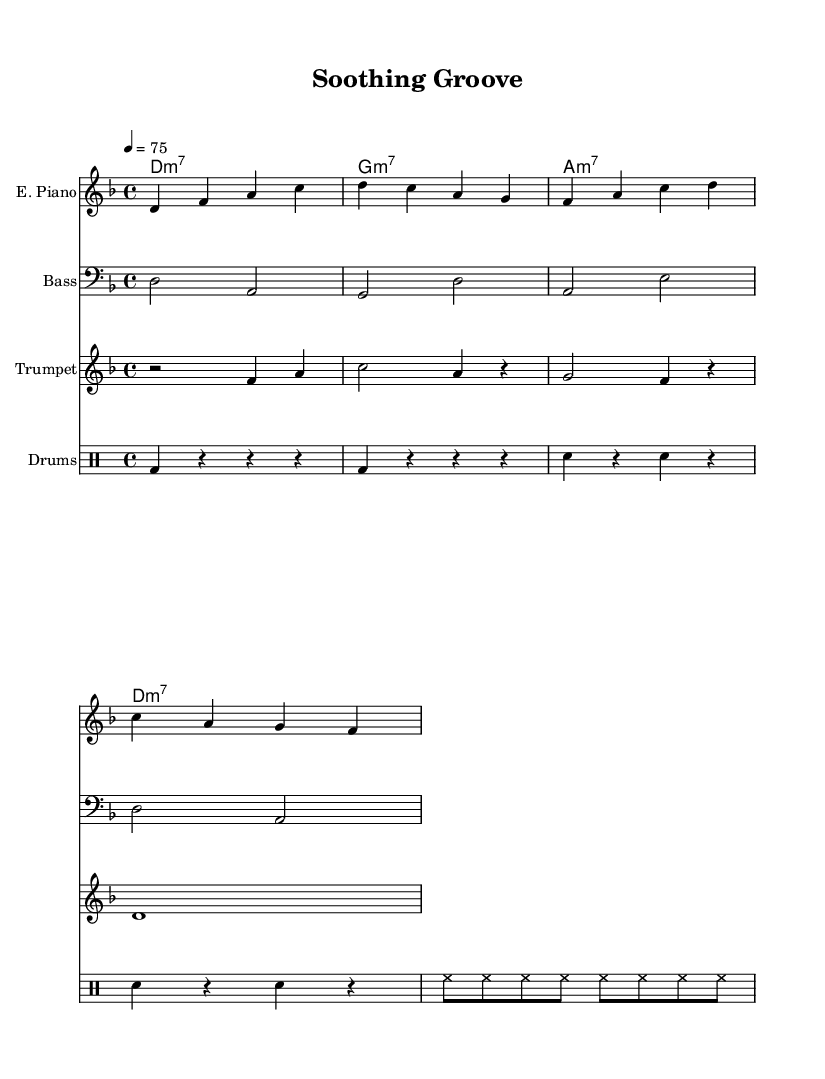What is the key signature of this music? The key signature indicated is D minor, which typically features one flat (B flat). Since no sharps or additional accidentals appear in the music, it confirms the key signature as D minor.
Answer: D minor What is the time signature of this music? The time signature shown at the beginning of the sheet music is 4/4, which means there are four beats in each measure and the quarter note receives one beat. This is a common time signature in many music styles, including funk.
Answer: 4/4 What is the tempo marking for this piece? The tempo marking indicates a speed of 75 beats per minute, written in the sheet music as "4 = 75." This suggests a moderate pace that is suitable for relaxing and mellow music.
Answer: 75 How many different instruments are included in this composition? The score displays four distinct instrument parts: electric piano, bass guitar, trumpet, and drums. Each part is represented on its own staff to illustrate the combination of sounds in the funk arrangement.
Answer: Four What kind of chord progression is used in the piece? The chord names presented show a progression consisting of D minor 7, G minor 7, A minor 7, followed by a repeat of D minor 7. This repeating structure provides a stable harmonic foundation typical in mellow funk music.
Answer: D minor 7, G minor 7, A minor 7 Which percussion instruments are featured in the drum part? The drum part is notated to include bass drum (bd), snare drum (sn), and hi-hat (hh). These instruments work together to create the rhythmic drive characteristic of funk music, contributing to its lively feel.
Answer: Bass drum, snare drum, hi-hat What defines the overall mood of the piece? The composition is designed to promote relaxation and stress relief, characterized by a mellow groove, moderate tempo, and smooth harmonic progressions. Funk music often supports this atmosphere through its rhythmic elements and instrumental interplay.
Answer: Relaxation 